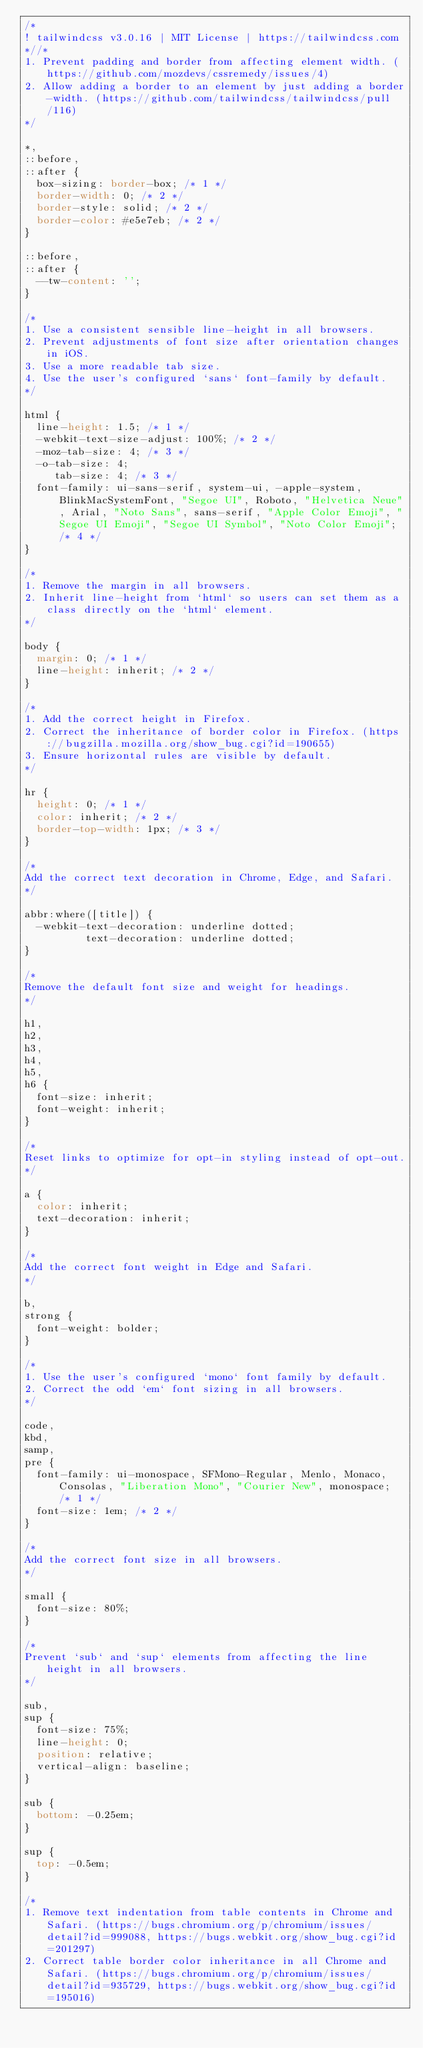Convert code to text. <code><loc_0><loc_0><loc_500><loc_500><_CSS_>/*
! tailwindcss v3.0.16 | MIT License | https://tailwindcss.com
*//*
1. Prevent padding and border from affecting element width. (https://github.com/mozdevs/cssremedy/issues/4)
2. Allow adding a border to an element by just adding a border-width. (https://github.com/tailwindcss/tailwindcss/pull/116)
*/

*,
::before,
::after {
  box-sizing: border-box; /* 1 */
  border-width: 0; /* 2 */
  border-style: solid; /* 2 */
  border-color: #e5e7eb; /* 2 */
}

::before,
::after {
  --tw-content: '';
}

/*
1. Use a consistent sensible line-height in all browsers.
2. Prevent adjustments of font size after orientation changes in iOS.
3. Use a more readable tab size.
4. Use the user's configured `sans` font-family by default.
*/

html {
  line-height: 1.5; /* 1 */
  -webkit-text-size-adjust: 100%; /* 2 */
  -moz-tab-size: 4; /* 3 */
  -o-tab-size: 4;
     tab-size: 4; /* 3 */
  font-family: ui-sans-serif, system-ui, -apple-system, BlinkMacSystemFont, "Segoe UI", Roboto, "Helvetica Neue", Arial, "Noto Sans", sans-serif, "Apple Color Emoji", "Segoe UI Emoji", "Segoe UI Symbol", "Noto Color Emoji"; /* 4 */
}

/*
1. Remove the margin in all browsers.
2. Inherit line-height from `html` so users can set them as a class directly on the `html` element.
*/

body {
  margin: 0; /* 1 */
  line-height: inherit; /* 2 */
}

/*
1. Add the correct height in Firefox.
2. Correct the inheritance of border color in Firefox. (https://bugzilla.mozilla.org/show_bug.cgi?id=190655)
3. Ensure horizontal rules are visible by default.
*/

hr {
  height: 0; /* 1 */
  color: inherit; /* 2 */
  border-top-width: 1px; /* 3 */
}

/*
Add the correct text decoration in Chrome, Edge, and Safari.
*/

abbr:where([title]) {
  -webkit-text-decoration: underline dotted;
          text-decoration: underline dotted;
}

/*
Remove the default font size and weight for headings.
*/

h1,
h2,
h3,
h4,
h5,
h6 {
  font-size: inherit;
  font-weight: inherit;
}

/*
Reset links to optimize for opt-in styling instead of opt-out.
*/

a {
  color: inherit;
  text-decoration: inherit;
}

/*
Add the correct font weight in Edge and Safari.
*/

b,
strong {
  font-weight: bolder;
}

/*
1. Use the user's configured `mono` font family by default.
2. Correct the odd `em` font sizing in all browsers.
*/

code,
kbd,
samp,
pre {
  font-family: ui-monospace, SFMono-Regular, Menlo, Monaco, Consolas, "Liberation Mono", "Courier New", monospace; /* 1 */
  font-size: 1em; /* 2 */
}

/*
Add the correct font size in all browsers.
*/

small {
  font-size: 80%;
}

/*
Prevent `sub` and `sup` elements from affecting the line height in all browsers.
*/

sub,
sup {
  font-size: 75%;
  line-height: 0;
  position: relative;
  vertical-align: baseline;
}

sub {
  bottom: -0.25em;
}

sup {
  top: -0.5em;
}

/*
1. Remove text indentation from table contents in Chrome and Safari. (https://bugs.chromium.org/p/chromium/issues/detail?id=999088, https://bugs.webkit.org/show_bug.cgi?id=201297)
2. Correct table border color inheritance in all Chrome and Safari. (https://bugs.chromium.org/p/chromium/issues/detail?id=935729, https://bugs.webkit.org/show_bug.cgi?id=195016)</code> 